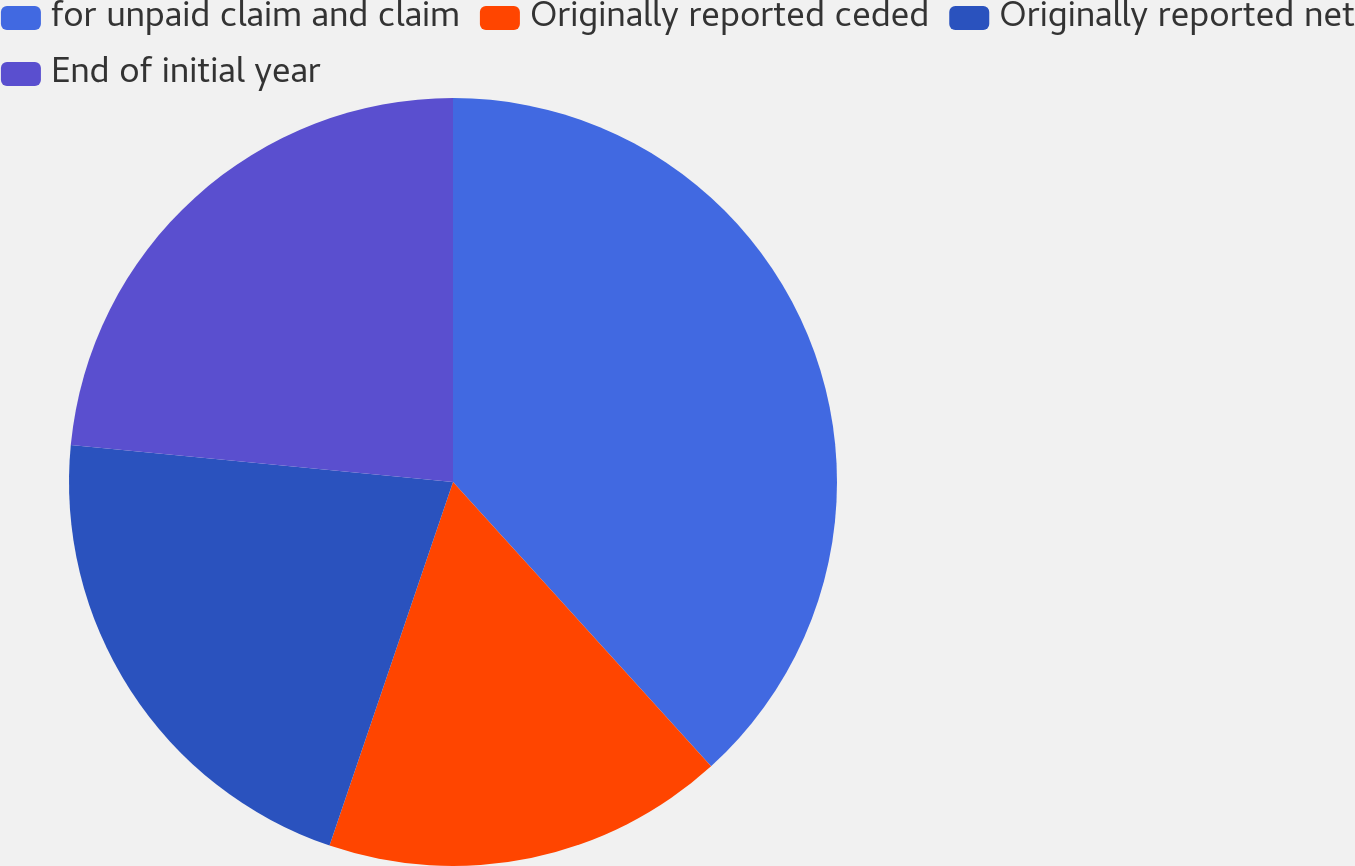Convert chart. <chart><loc_0><loc_0><loc_500><loc_500><pie_chart><fcel>for unpaid claim and claim<fcel>Originally reported ceded<fcel>Originally reported net<fcel>End of initial year<nl><fcel>38.27%<fcel>16.94%<fcel>21.33%<fcel>23.46%<nl></chart> 